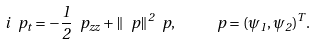Convert formula to latex. <formula><loc_0><loc_0><loc_500><loc_500>i \ p _ { t } = - \frac { 1 } { 2 } \ p _ { z z } + \| \ p \| ^ { 2 } \ p , \quad \ p = ( \psi _ { 1 } , \psi _ { 2 } ) ^ { T } .</formula> 